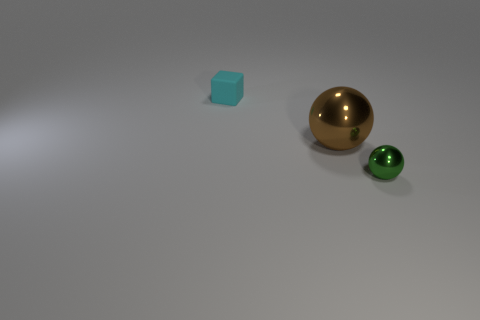Subtract all green balls. How many balls are left? 1 Subtract all purple blocks. How many green spheres are left? 1 Subtract all tiny blocks. Subtract all yellow matte cylinders. How many objects are left? 2 Add 2 green metal spheres. How many green metal spheres are left? 3 Add 2 brown objects. How many brown objects exist? 3 Add 1 cyan rubber objects. How many objects exist? 4 Subtract 0 brown cylinders. How many objects are left? 3 Subtract all spheres. How many objects are left? 1 Subtract all blue balls. Subtract all red blocks. How many balls are left? 2 